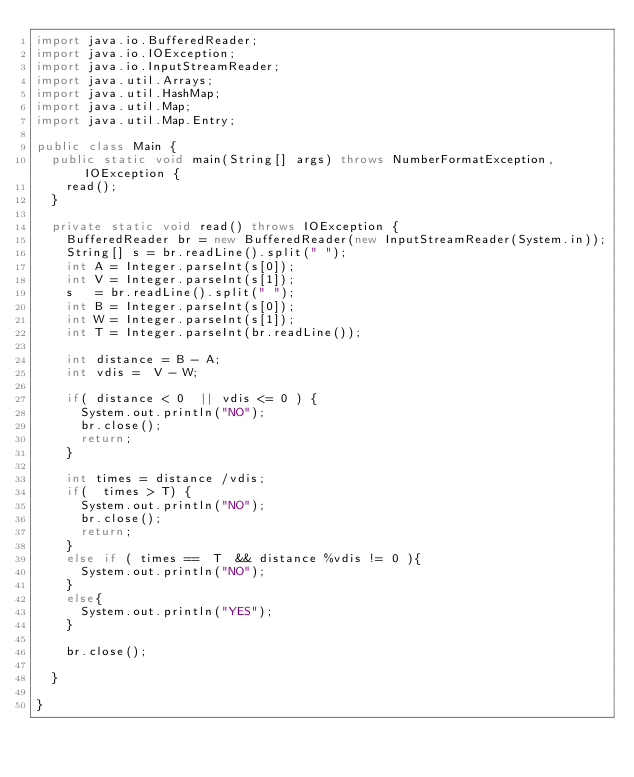<code> <loc_0><loc_0><loc_500><loc_500><_Java_>import java.io.BufferedReader;
import java.io.IOException;
import java.io.InputStreamReader;
import java.util.Arrays;
import java.util.HashMap;
import java.util.Map;
import java.util.Map.Entry;

public class Main {
	public static void main(String[] args) throws NumberFormatException, IOException {
		read();
	}

	private static void read() throws IOException {
		BufferedReader br = new BufferedReader(new InputStreamReader(System.in));
		String[] s = br.readLine().split(" ");
		int A = Integer.parseInt(s[0]);
		int V = Integer.parseInt(s[1]);
		s   = br.readLine().split(" ");
		int B = Integer.parseInt(s[0]);
		int W = Integer.parseInt(s[1]);
		int T = Integer.parseInt(br.readLine());
		
		int distance = B - A;
		int vdis =  V - W;
		
		if( distance < 0  || vdis <= 0 ) {
			System.out.println("NO");
			br.close();
			return;
		}
		
		int times = distance /vdis;
		if(  times > T) {
			System.out.println("NO");
			br.close();
			return;
		}
		else if ( times ==  T  && distance %vdis != 0 ){
			System.out.println("NO");
		}
		else{
			System.out.println("YES");
		}
		
		br.close();

	}

}
</code> 